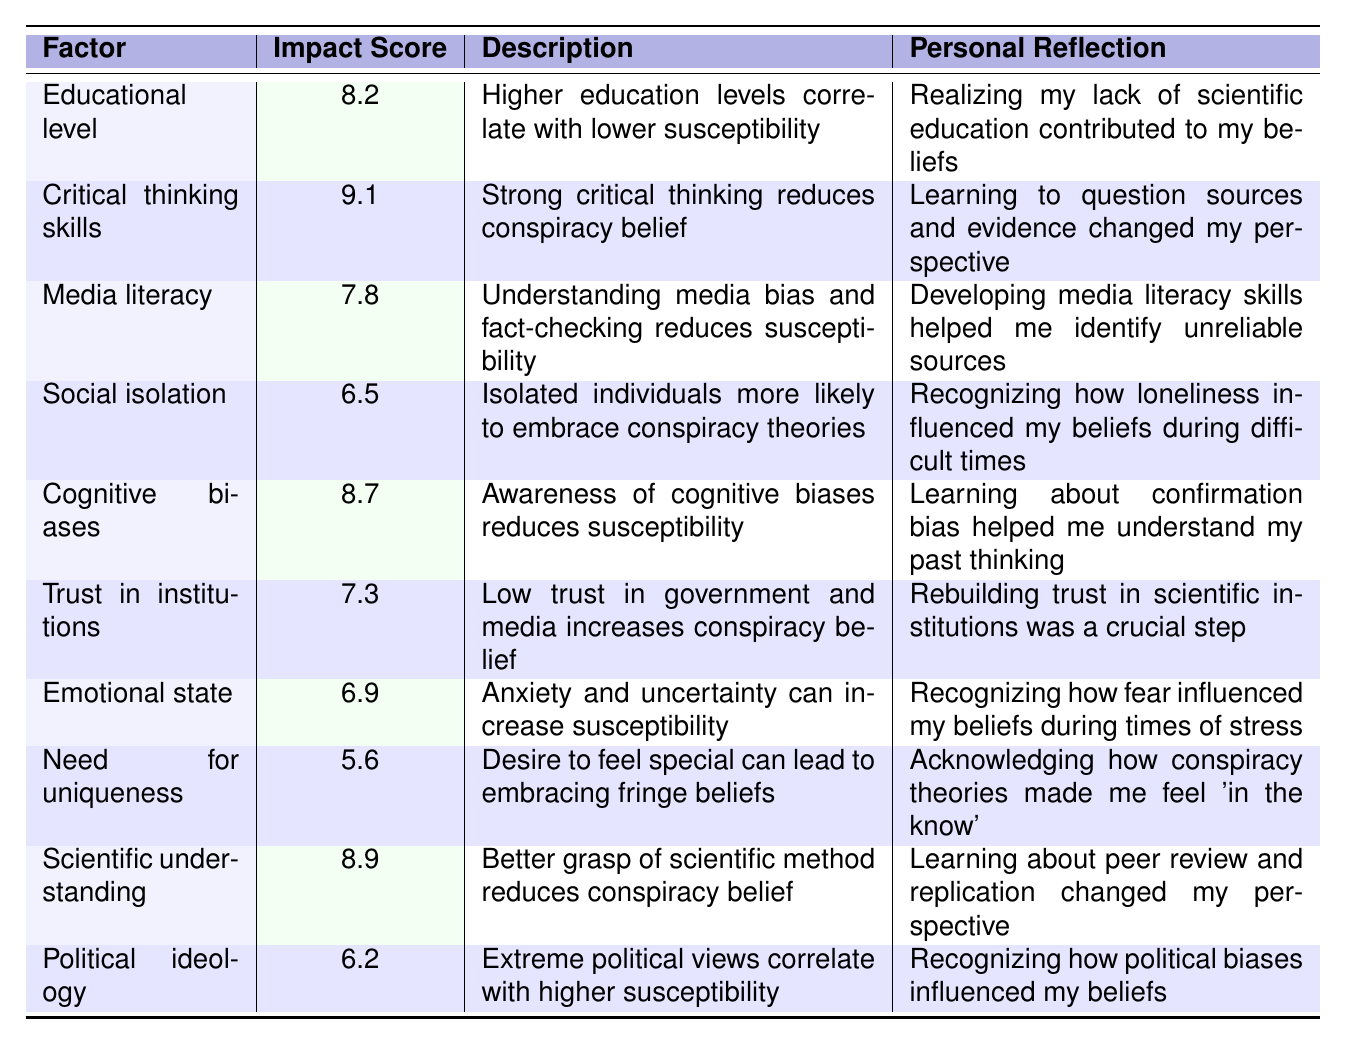What is the factor with the highest impact score? The table lists impact scores for various factors. By comparing the scores, we see that "Critical thinking skills" has the highest score of 9.1.
Answer: Critical thinking skills Which factor correlates with lower susceptibility to conspiracy theories based on the table? The table includes factors that affect susceptibility. "Educational level" has an impact score of 8.2, indicating that higher education levels correlate with lower susceptibility.
Answer: Educational level Calculate the average impact score of the factors related to cognitive understanding (Critical thinking skills, Scientific understanding, Cognitive biases, and Educational level). The impact scores for the selected factors are 9.1 (Critical thinking skills), 8.9 (Scientific understanding), 8.7 (Cognitive biases), and 8.2 (Educational level). Summing these gives 9.1 + 8.9 + 8.7 + 8.2 = 34.9. There are 4 factors, so the average is 34.9 / 4 = 8.725.
Answer: 8.725 Is there a factor that has an impact score lower than 6.5 and is associated with conspiracy theories? The table lists "Need for uniqueness" with an impact score of 5.6, which is below 6.5 and suggests a connection to conspiracy theories.
Answer: Yes What is the difference in impact scores between "Critical thinking skills" and "Political ideology"? The impact score for "Critical thinking skills" is 9.1 and for "Political ideology" it is 6.2. The difference is 9.1 - 6.2 = 2.9.
Answer: 2.9 Which two factors have impact scores closest in value, and what are those scores? By comparing the impact scores, "Social isolation" (6.5) and "Emotional state" (6.9) are the closest, with a difference of 0.4.
Answer: Social isolation (6.5) and Emotional state (6.9) How many factors have an impact score above 7? By examining the table, the factors with impact scores above 7 are "Critical thinking skills" (9.1), "Scientific understanding" (8.9), "Cognitive biases" (8.7), "Educational level" (8.2), and "Media literacy" (7.8), totaling 5 factors.
Answer: 5 What is the relationship between "Trust in institutions" and "Social isolation" regarding their impact scores? "Trust in institutions" has an impact score of 7.3, while "Social isolation" has a score of 6.5. The impact of trust in institutions is higher, indicating that low trust correlates with higher susceptibility than social isolation.
Answer: Trust in institutions is higher Does higher education correlate with lower susceptibility to conspiracy theories according to the table? The description for "Educational level" indicates that higher education levels correlate with lower susceptibility to conspiracy theories. Therefore, the statement is true.
Answer: Yes Which factors suggest emotional or psychological influences on susceptibility to conspiracy theories? The table mentions "Emotional state" (6.9) and "Social isolation" (6.5), which both indicate influences tied to emotional and psychological aspects.
Answer: Emotional state and Social isolation 